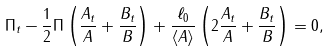Convert formula to latex. <formula><loc_0><loc_0><loc_500><loc_500>\Pi _ { t } - \frac { 1 } { 2 } \Pi \left ( \frac { A _ { t } } { A } + \frac { B _ { t } } { B } \right ) + \frac { \ell _ { 0 } } { \langle A \rangle } \left ( 2 \frac { A _ { t } } { A } + \frac { B _ { t } } { B } \right ) = 0 ,</formula> 